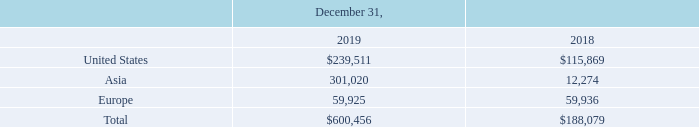ADVANCED ENERGY INDUSTRIES, INC. NOTES TO CONSOLIDATED FINANCIAL STATEMENTS – (continued) (in thousands, except per share amounts)
The following table summarizes long-lived assets by geographic area as of December 31, 2019 and December 31, 2018:
Long-lived assets include property and equipment, operating lease right-of-use assets, goodwill and other intangible assets.
What was the amount of long-lived assets in United States in 2019?
Answer scale should be: thousand. 239,511. What was the amount of long-lived assets in Europe in 2019?
Answer scale should be: thousand. 59,925. What does Long-lived assets include? Property and equipment, operating lease right-of-use assets, goodwill and other intangible assets. What was the change in the amount of long-lived assets between 2018 and 2019 in United States?
Answer scale should be: thousand. $239,511-$115,869
Answer: 123642. What is the sum of the highest two long-lived assets in 2018?
Answer scale should be: thousand. $115,869+59,936
Answer: 175805. What was the percentage change in total long-lived assets between 2018 and 2019?
Answer scale should be: percent. ($600,456-$188,079)/$188,079
Answer: 219.26. 